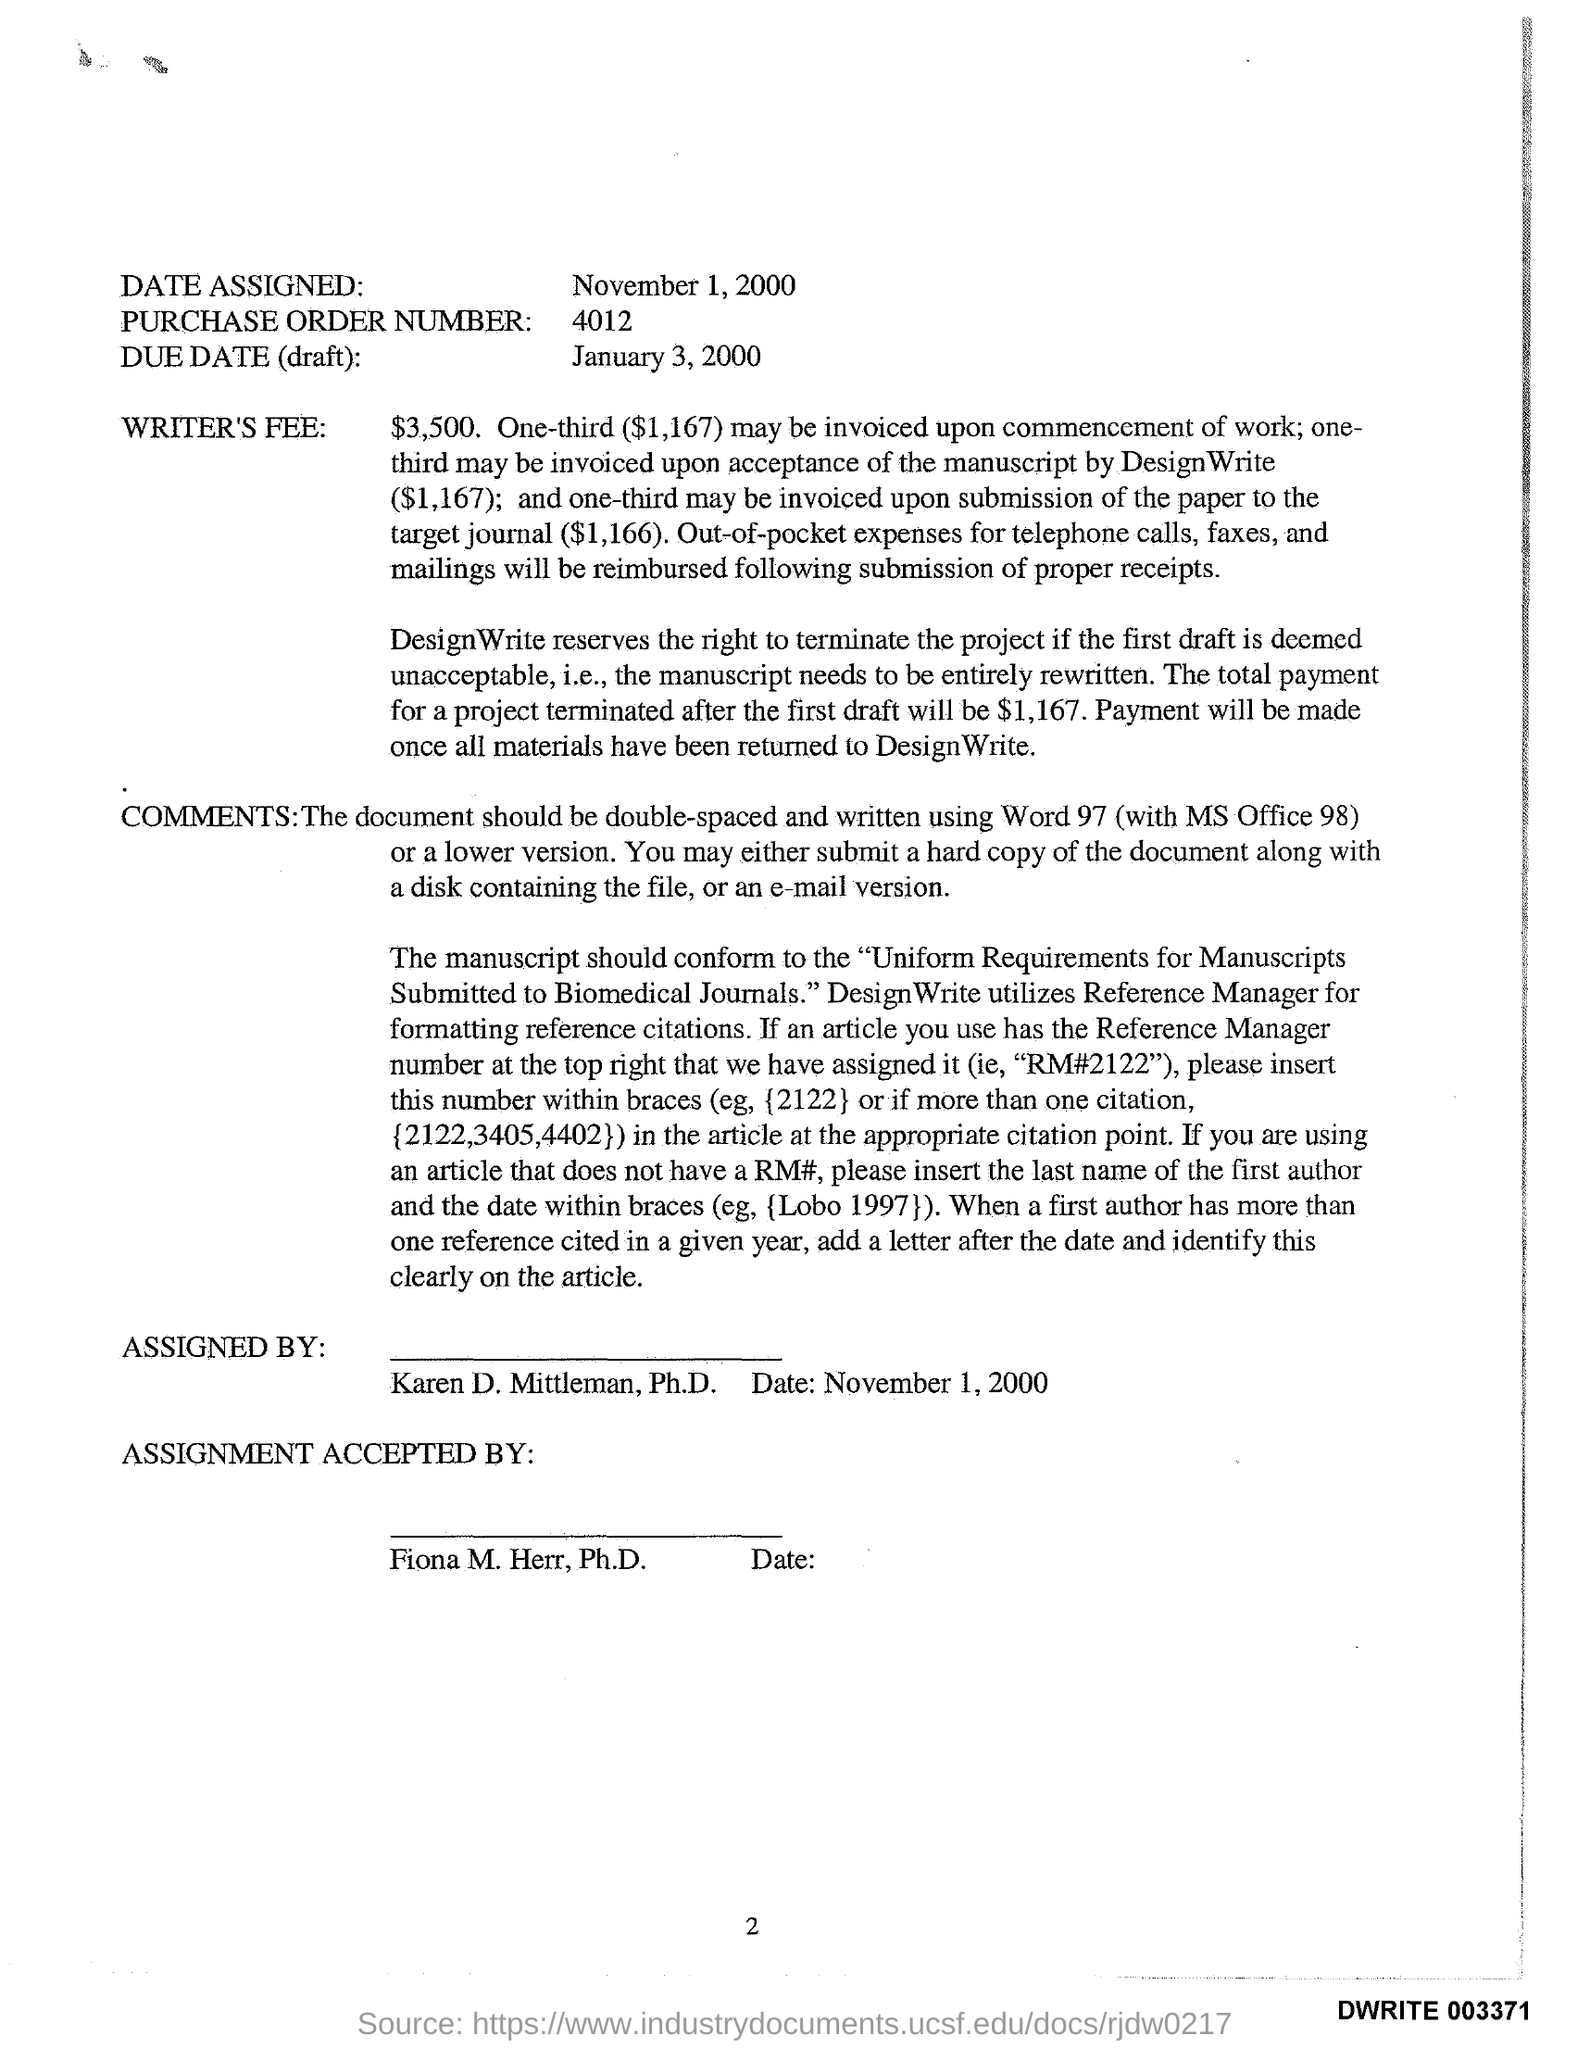What is the Date Assigned?
Offer a terse response. November 1, 2000. What is the Purchase Order Number?
Ensure brevity in your answer.  4012. Who is it Assigned By?
Keep it short and to the point. Karen D. Mittleman, Ph.D. The Assignment was Accepted By?
Make the answer very short. Fiona m. herr. What is the Writer's Fee?
Your answer should be very brief. $3,500. 